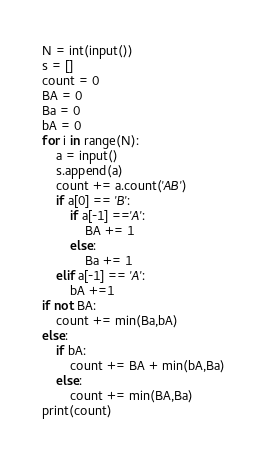Convert code to text. <code><loc_0><loc_0><loc_500><loc_500><_Python_>N = int(input())
s = []
count = 0
BA = 0
Ba = 0
bA = 0
for i in range(N):
    a = input()
    s.append(a)
    count += a.count('AB')
    if a[0] == 'B':
        if a[-1] =='A':
            BA += 1
        else:
            Ba += 1
    elif a[-1] == 'A':
        bA +=1
if not BA:
    count += min(Ba,bA)
else:
    if bA:
        count += BA + min(bA,Ba)
    else:
        count += min(BA,Ba)
print(count)</code> 